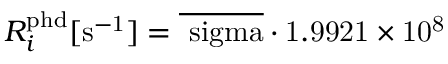Convert formula to latex. <formula><loc_0><loc_0><loc_500><loc_500>R _ { i } ^ { p h d } [ { s ^ { - 1 } } ] = \overline { \ s i g m a } \cdot 1 . 9 9 2 1 \times 1 0 ^ { 8 }</formula> 